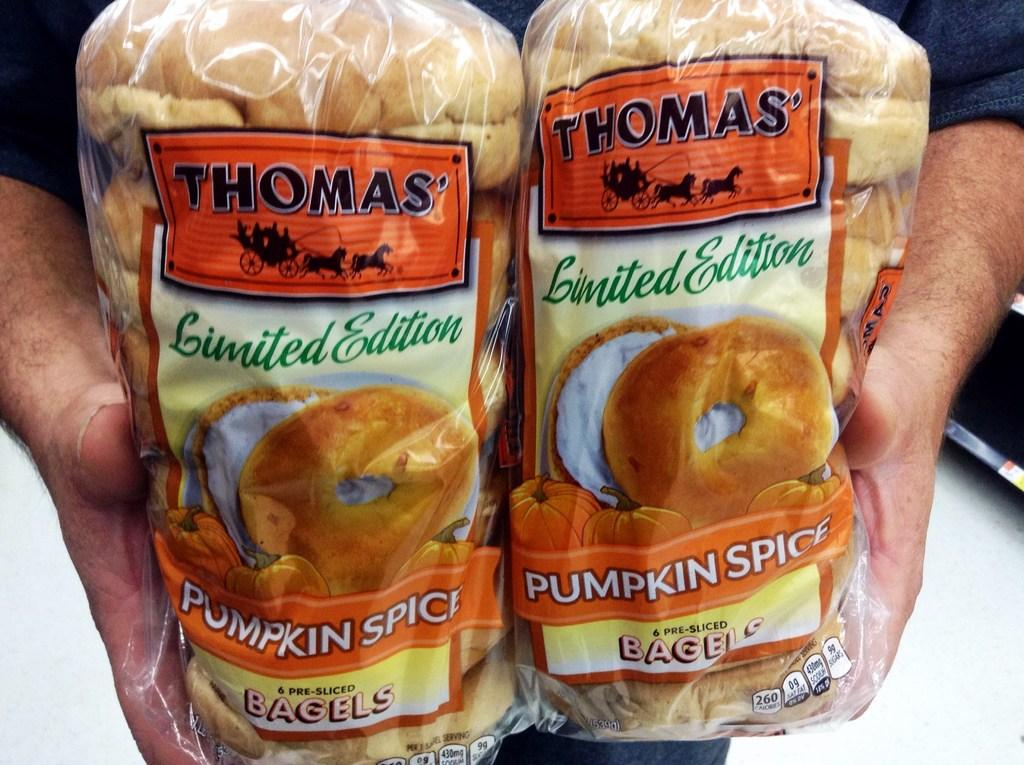What is present in the image? There is a person in the image. What is the person holding in their hands? The person is holding packed food in their hands. Can you see the friend of the person in the image? There is no mention of a friend in the image, so it cannot be determined if the person has a friend present. 